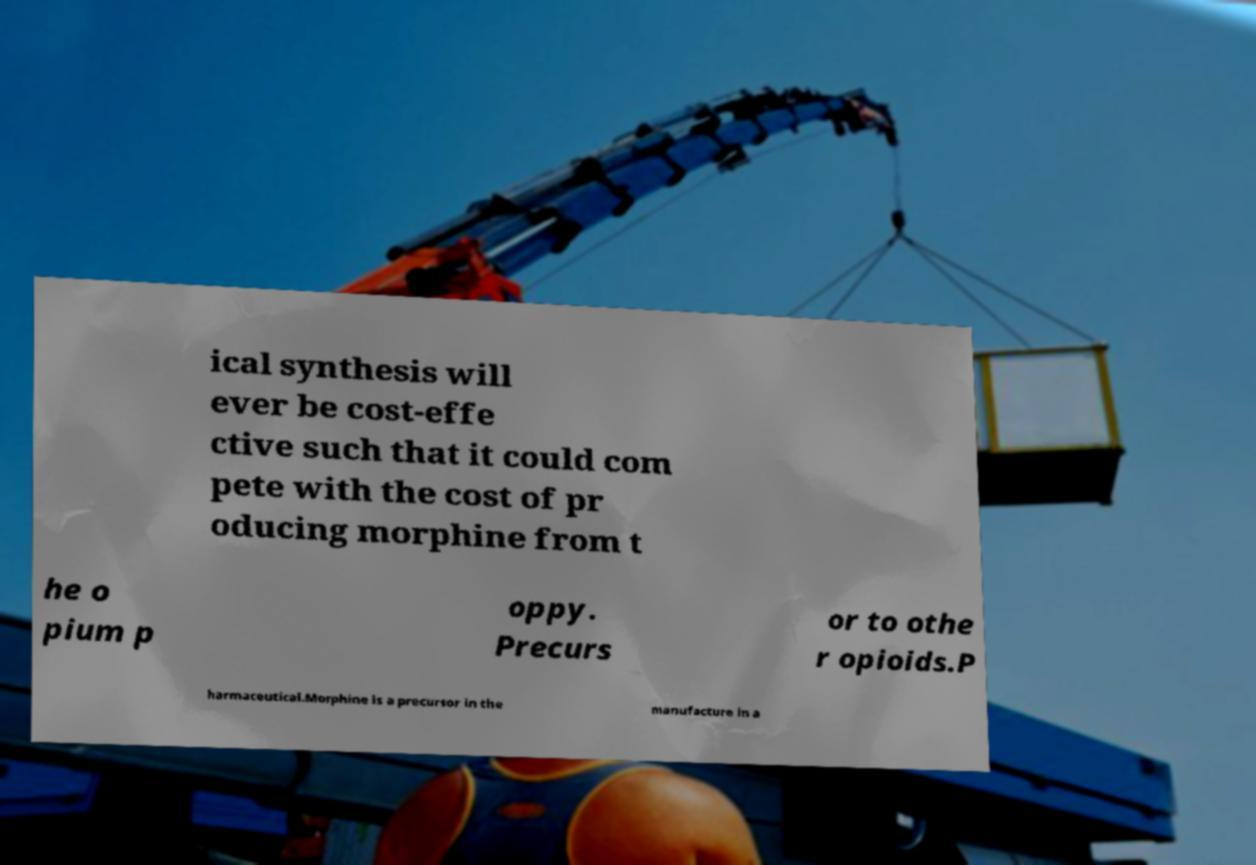Could you assist in decoding the text presented in this image and type it out clearly? ical synthesis will ever be cost-effe ctive such that it could com pete with the cost of pr oducing morphine from t he o pium p oppy. Precurs or to othe r opioids.P harmaceutical.Morphine is a precursor in the manufacture in a 